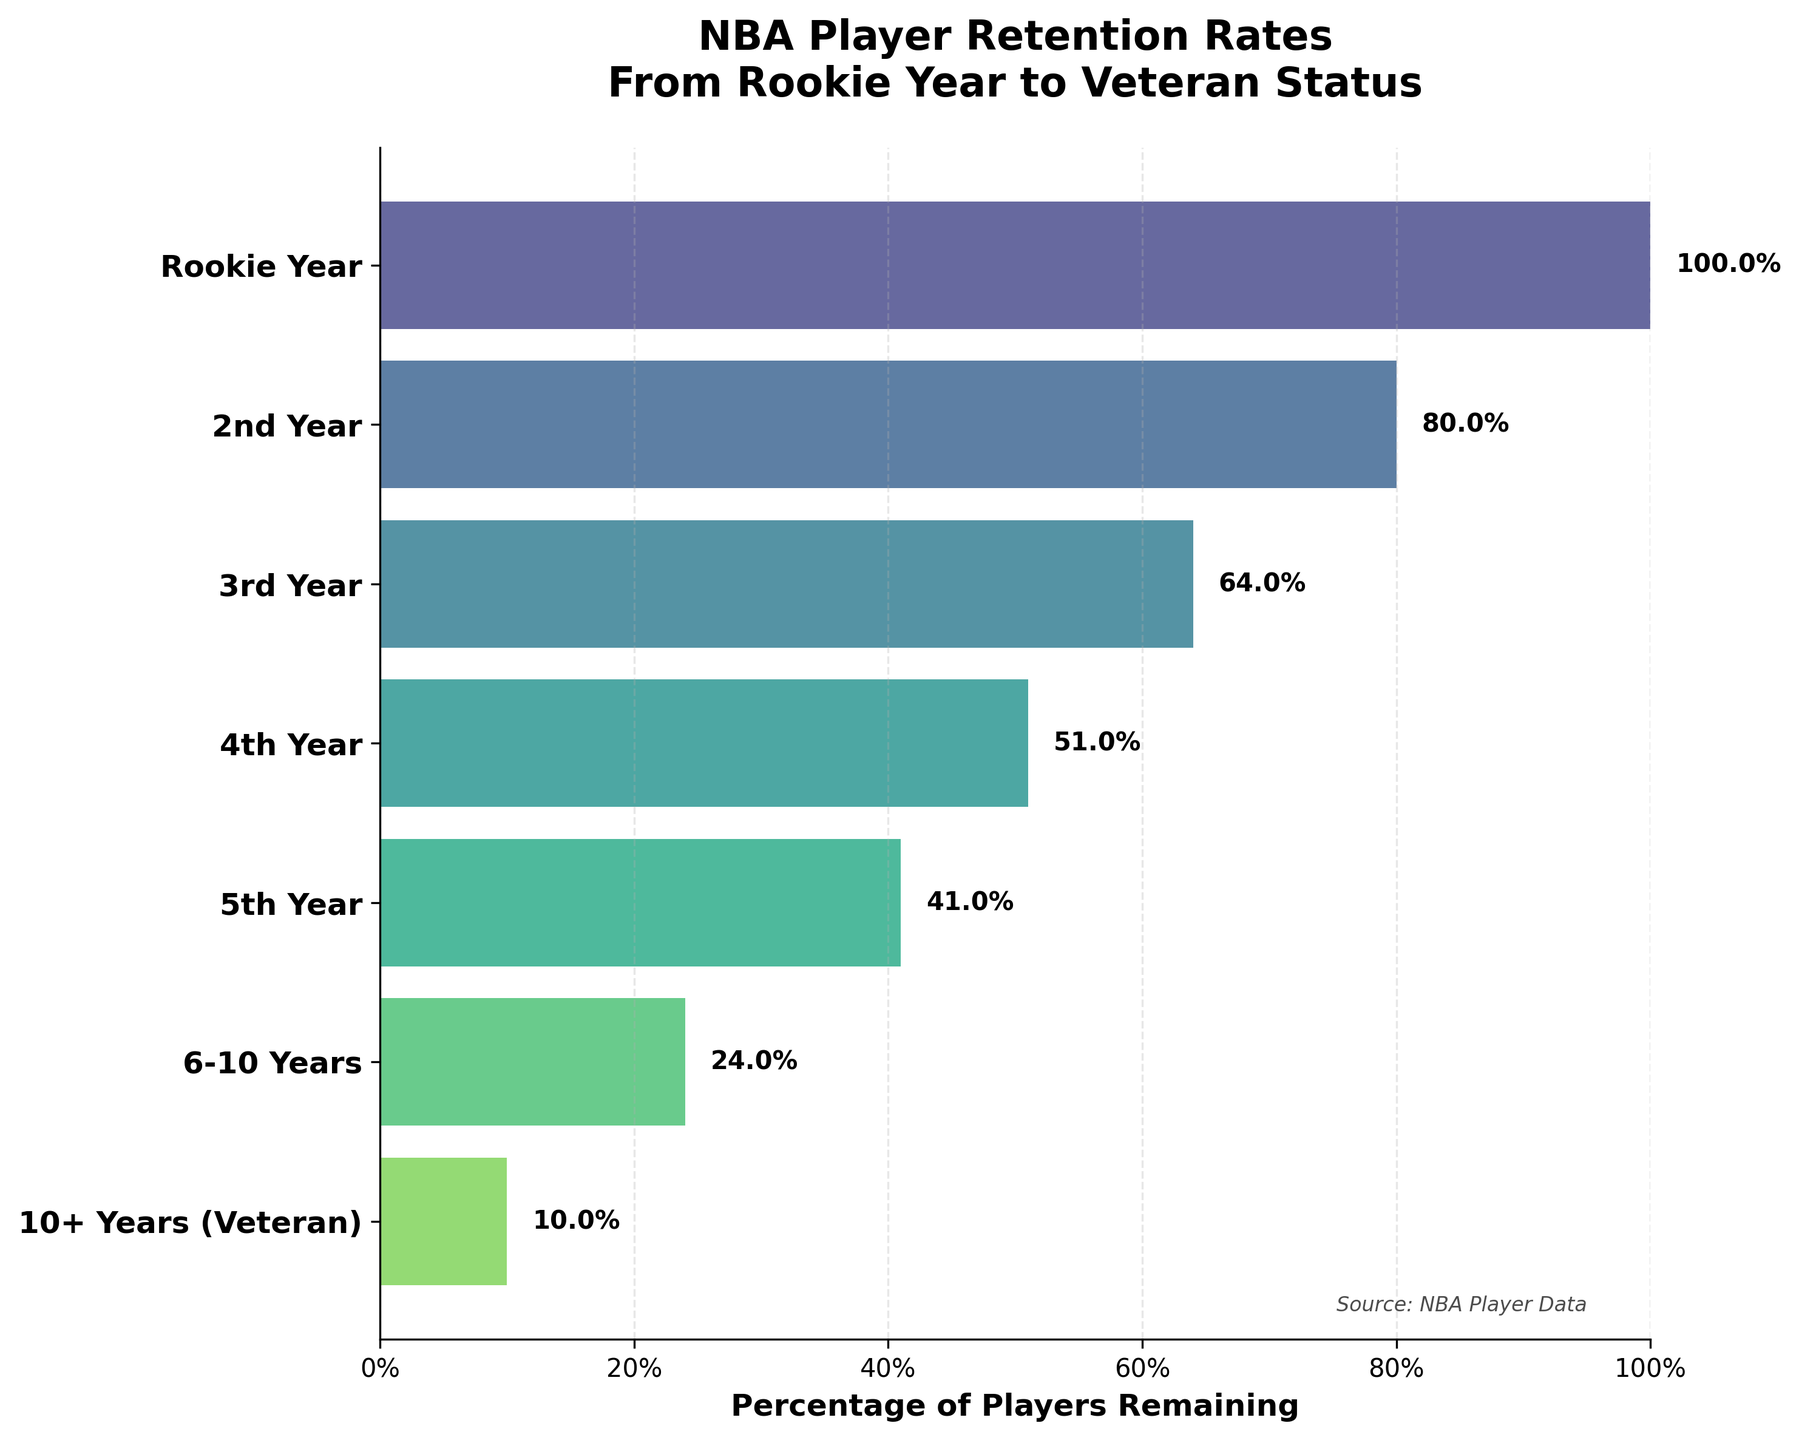When does the largest drop in player retention occur? The largest drop in player retention occurs between the Rookie Year and the 2nd Year, where the percentage decreases from 100% to 80%, a 20% drop.
Answer: Between Rookie Year and 2nd Year How many players remain by the 3rd Year? According to the funnel chart, by the 3rd Year, there are 288 players remaining.
Answer: 288 What percentage of players from the Rookie Year reach veteran status? The percentage of players from the Rookie Year that reach veteran status (10+ Years) is 10%.
Answer: 10% Which stage has the second smallest number of players remaining? The 6-10 Years stage has the second smallest number of players remaining with 110 players.
Answer: 6-10 Years By what percentage does player retention drop from the 3rd Year to the 4th Year? The retention drops from 64% in the 3rd Year to 51% in the 4th Year, which is a drop of 13%.
Answer: 13% What is the average retention percentage from 2nd Year to the 5th Year? The percentages from 2nd Year to 5th Year are 80%, 64%, 51%, and 41%. Their sum is 80 + 64 + 51 + 41 = 236. The average is 236 / 4 = 59%.
Answer: 59% At which stage does the player retention percentage first fall below 50%? The player retention percentage first falls below 50% at the 4th Year stage, where it is 41%.
Answer: 4th Year How does the retention rate change after the 6th Year? After the 6th Year (6-10 Years), the retention rate drops from 24% to 10%, a decline of 14%.
Answer: Declines by 14% What is the difference in the number of players remaining between the 5th Year and the 10+ Years (Veteran) stage? The number of players remaining in the 5th Year is 184 and in the 10+ Years (Veteran) stage is 45. The difference is 184 - 45 = 139.
Answer: 139 Which stage sees the smallest percentage drop in player retention compared to the previous stage? The smallest percentage drop in player retention compared to the previous stage occurs between the 3rd Year (64%) and the 4th Year (51%), a drop of 13%.
Answer: Between 3rd Year and 4th Year 